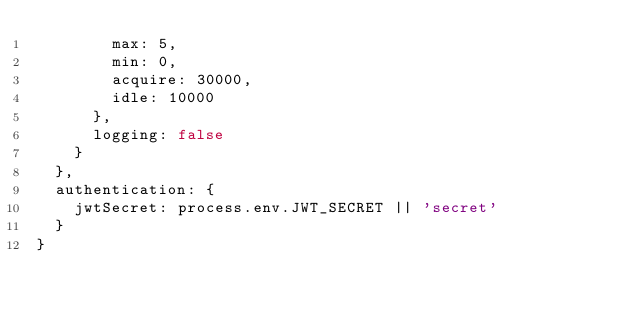<code> <loc_0><loc_0><loc_500><loc_500><_JavaScript_>        max: 5,
        min: 0,
        acquire: 30000,
        idle: 10000
      },
      logging: false
    }
  },
  authentication: {
    jwtSecret: process.env.JWT_SECRET || 'secret'
  }
}
</code> 